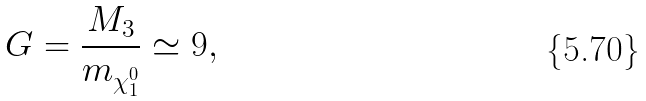<formula> <loc_0><loc_0><loc_500><loc_500>G = \frac { M _ { 3 } } { m _ { \chi _ { 1 } ^ { 0 } } } \simeq 9 ,</formula> 